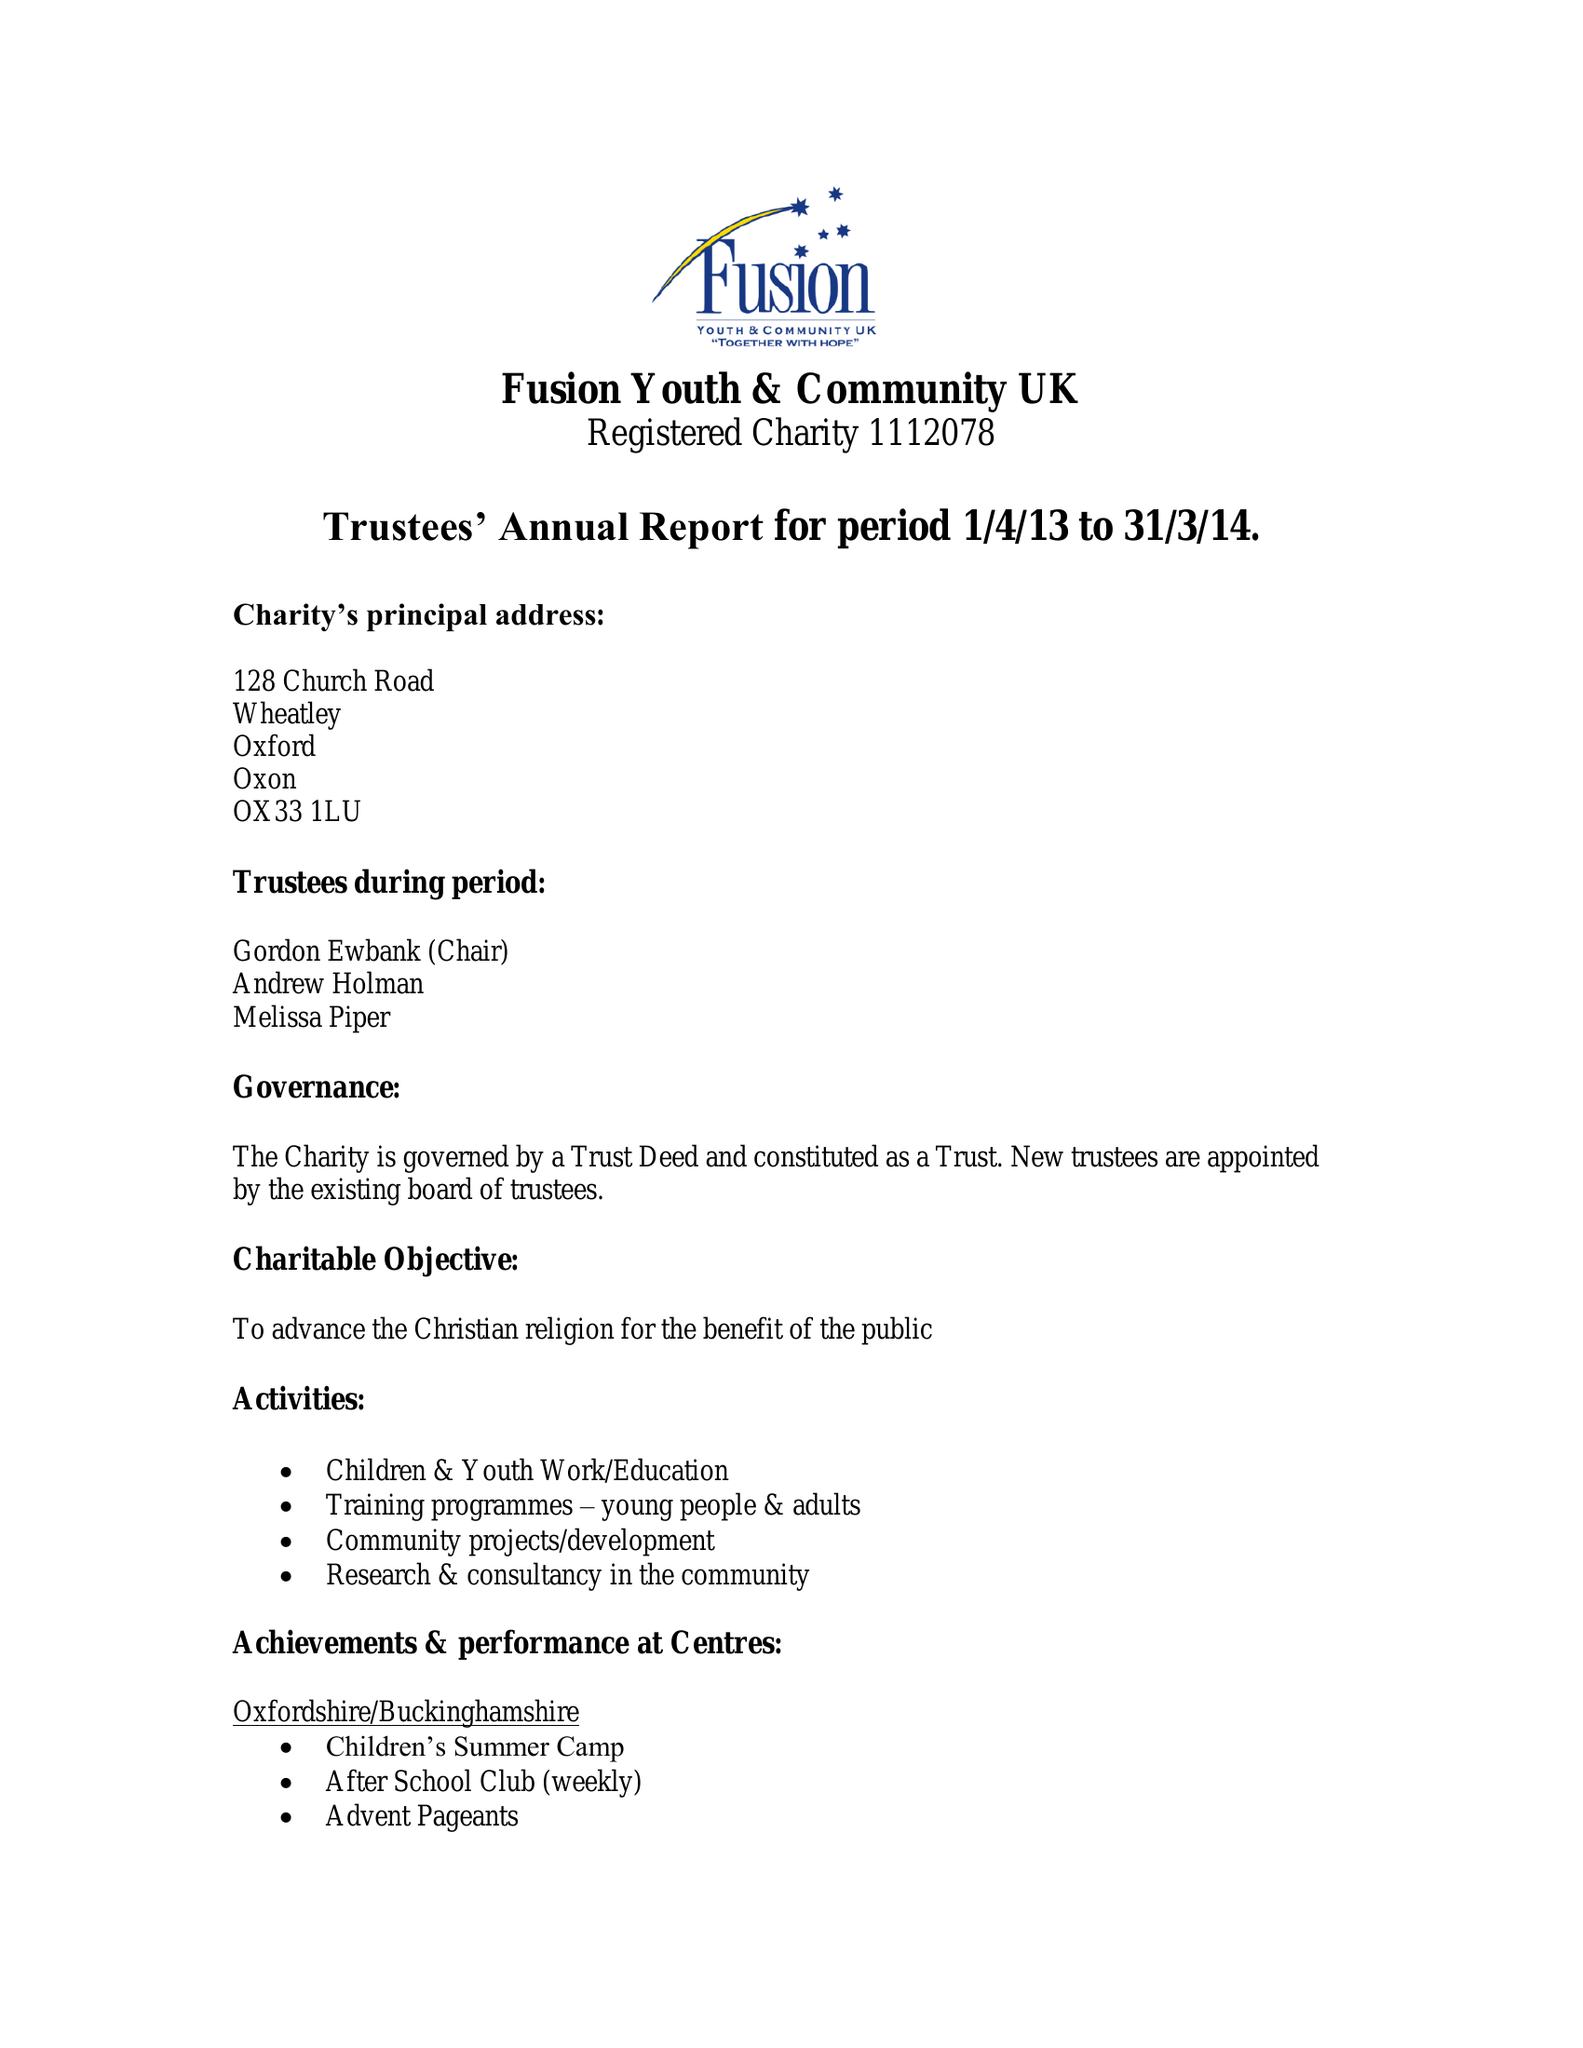What is the value for the address__street_line?
Answer the question using a single word or phrase. None 